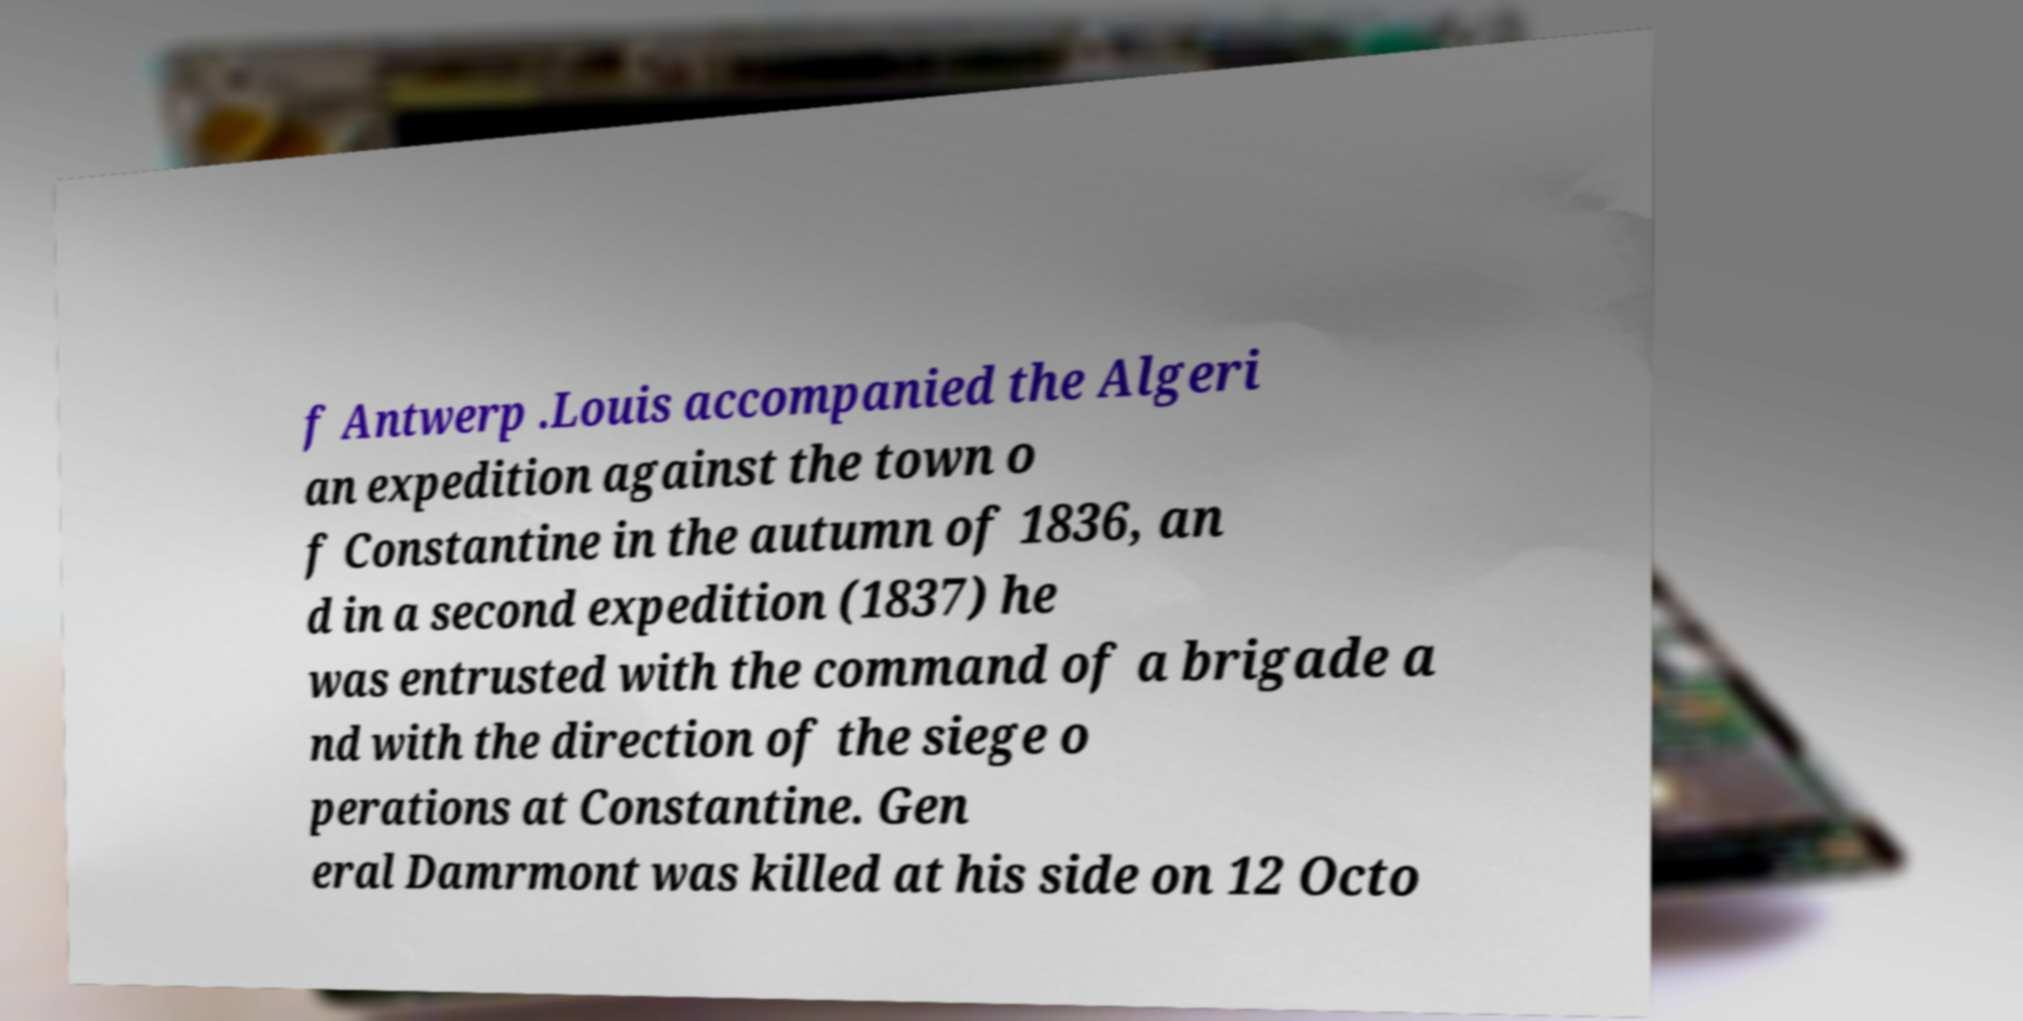What messages or text are displayed in this image? I need them in a readable, typed format. f Antwerp .Louis accompanied the Algeri an expedition against the town o f Constantine in the autumn of 1836, an d in a second expedition (1837) he was entrusted with the command of a brigade a nd with the direction of the siege o perations at Constantine. Gen eral Damrmont was killed at his side on 12 Octo 